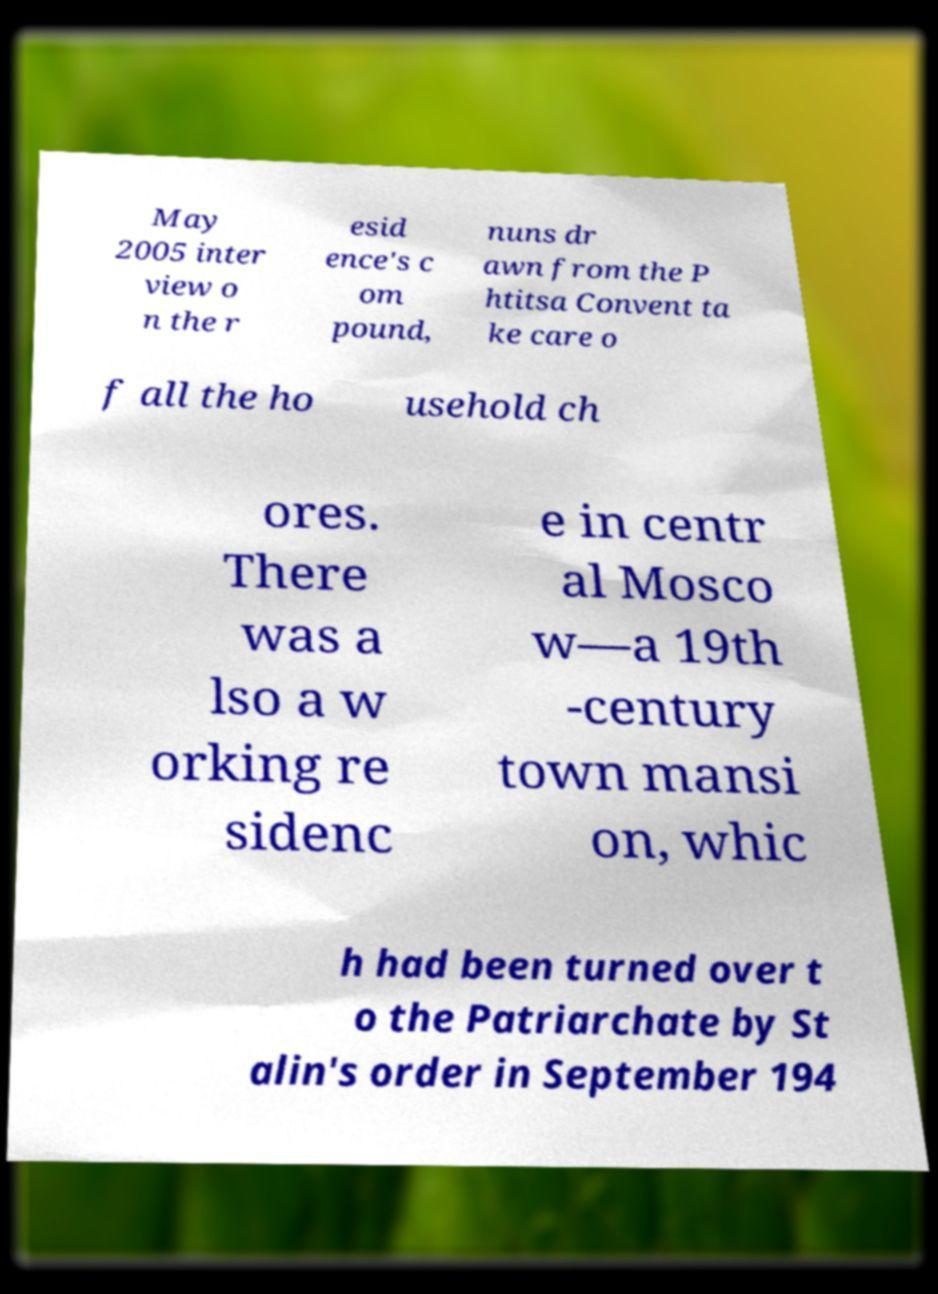Could you extract and type out the text from this image? May 2005 inter view o n the r esid ence's c om pound, nuns dr awn from the P htitsa Convent ta ke care o f all the ho usehold ch ores. There was a lso a w orking re sidenc e in centr al Mosco w—a 19th -century town mansi on, whic h had been turned over t o the Patriarchate by St alin's order in September 194 